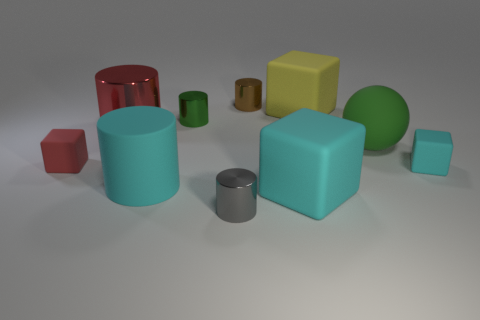How many tiny green metal cylinders are there?
Ensure brevity in your answer.  1. There is a cyan rubber thing that is to the right of the brown cylinder and on the left side of the rubber ball; what shape is it?
Your answer should be very brief. Cube. There is a small cyan object that is right of the small thing that is behind the big cube that is behind the small cyan matte object; what shape is it?
Your answer should be very brief. Cube. There is a thing that is in front of the large red thing and behind the small red rubber block; what is its material?
Provide a succinct answer. Rubber. How many cyan cubes are the same size as the red rubber object?
Ensure brevity in your answer.  1. How many metallic objects are yellow balls or big objects?
Offer a very short reply. 1. What is the small green cylinder made of?
Your answer should be very brief. Metal. There is a small gray cylinder; how many blocks are left of it?
Your answer should be compact. 1. Is the cyan object right of the big yellow object made of the same material as the large cyan cylinder?
Offer a terse response. Yes. What number of tiny red things have the same shape as the large yellow rubber object?
Make the answer very short. 1. 